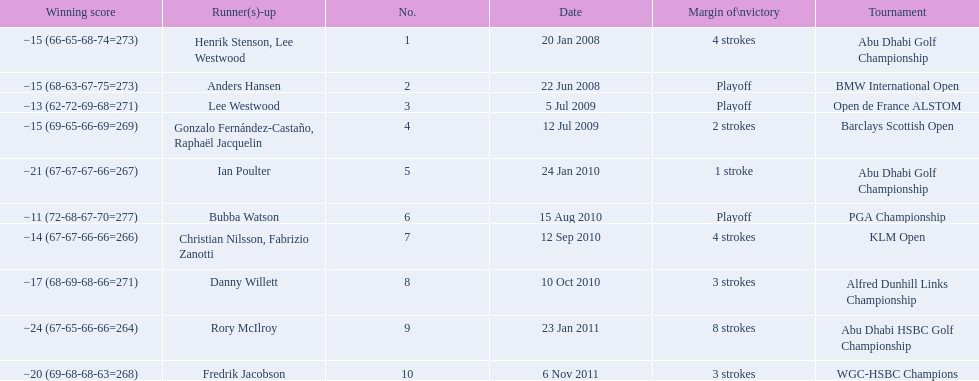What were all of the tournaments martin played in? Abu Dhabi Golf Championship, BMW International Open, Open de France ALSTOM, Barclays Scottish Open, Abu Dhabi Golf Championship, PGA Championship, KLM Open, Alfred Dunhill Links Championship, Abu Dhabi HSBC Golf Championship, WGC-HSBC Champions. And how many strokes did he score? −15 (66-65-68-74=273), −15 (68-63-67-75=273), −13 (62-72-69-68=271), −15 (69-65-66-69=269), −21 (67-67-67-66=267), −11 (72-68-67-70=277), −14 (67-67-66-66=266), −17 (68-69-68-66=271), −24 (67-65-66-66=264), −20 (69-68-68-63=268). What about during barclays and klm? −15 (69-65-66-69=269), −14 (67-67-66-66=266). How many more were scored in klm? 2 strokes. 